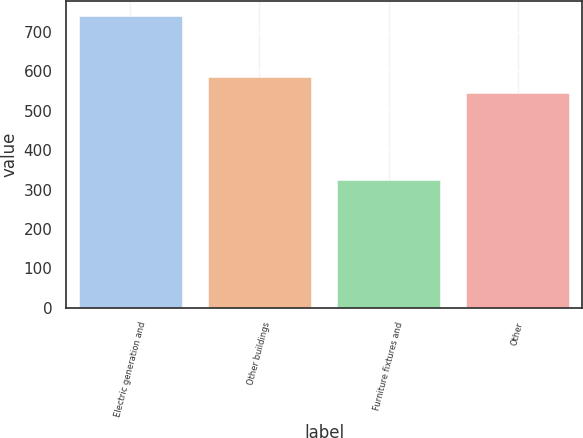Convert chart. <chart><loc_0><loc_0><loc_500><loc_500><bar_chart><fcel>Electric generation and<fcel>Other buildings<fcel>Furniture fixtures and<fcel>Other<nl><fcel>740<fcel>585.5<fcel>325<fcel>544<nl></chart> 